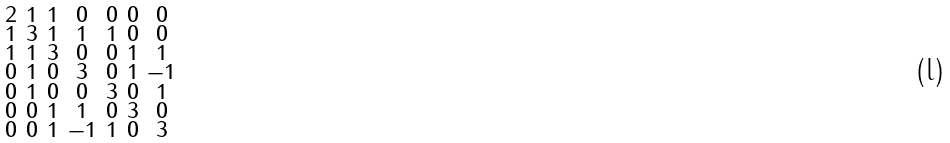Convert formula to latex. <formula><loc_0><loc_0><loc_500><loc_500>\begin{smallmatrix} 2 & 1 & 1 & 0 & 0 & 0 & 0 \\ 1 & 3 & 1 & 1 & 1 & 0 & 0 \\ 1 & 1 & 3 & 0 & 0 & 1 & 1 \\ 0 & 1 & 0 & 3 & 0 & 1 & - 1 \\ 0 & 1 & 0 & 0 & 3 & 0 & 1 \\ 0 & 0 & 1 & 1 & 0 & 3 & 0 \\ 0 & 0 & 1 & - 1 & 1 & 0 & 3 \end{smallmatrix}</formula> 